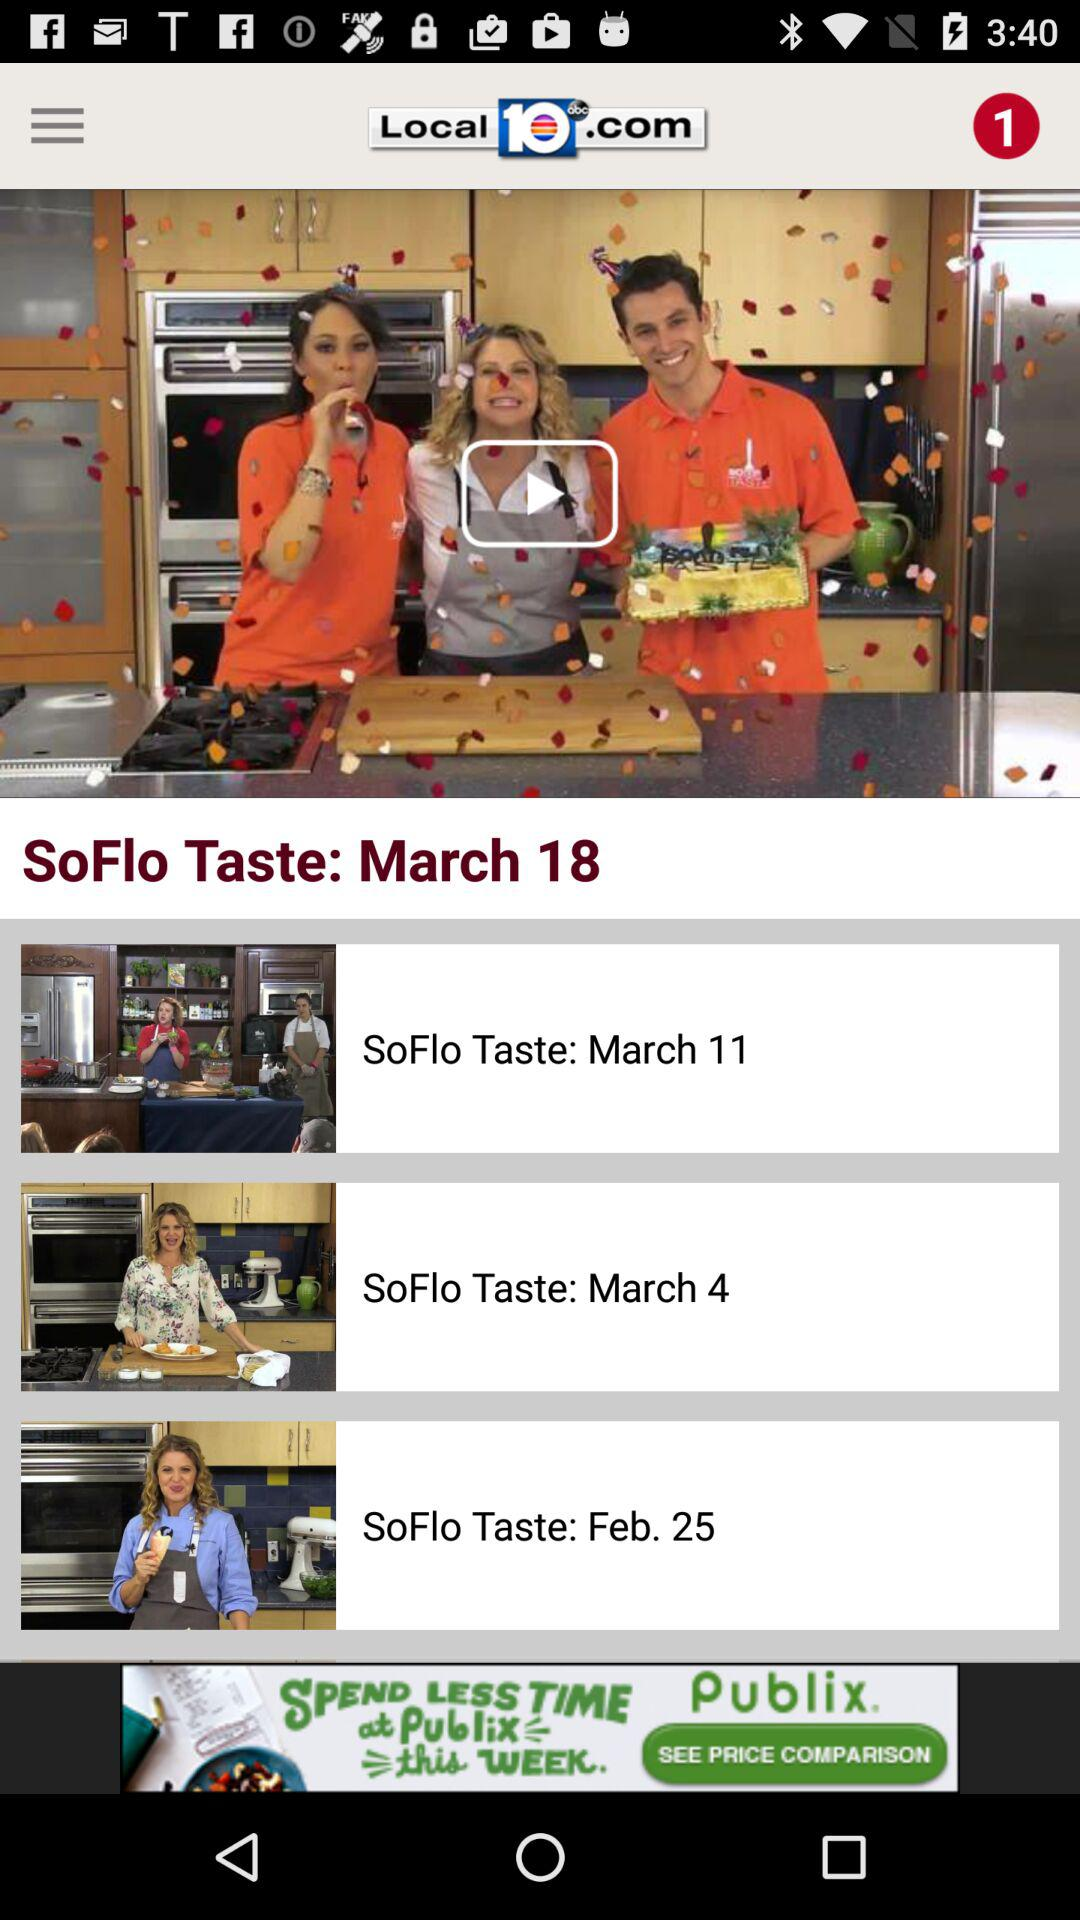What is the date of the "SoFlo Taste" video currently being shown? The date is March 18. 